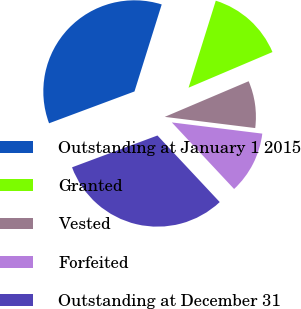<chart> <loc_0><loc_0><loc_500><loc_500><pie_chart><fcel>Outstanding at January 1 2015<fcel>Granted<fcel>Vested<fcel>Forfeited<fcel>Outstanding at December 31<nl><fcel>35.5%<fcel>13.78%<fcel>8.35%<fcel>11.07%<fcel>31.29%<nl></chart> 